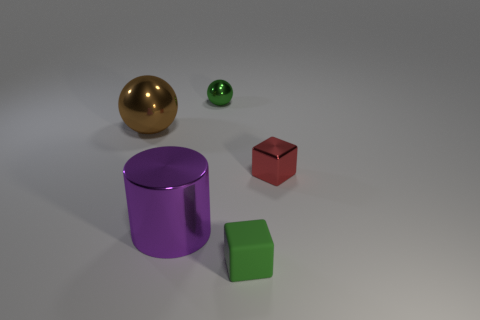Is the size of the green thing behind the green cube the same as the green matte block?
Ensure brevity in your answer.  Yes. There is a thing that is on the right side of the purple thing and behind the small red shiny thing; what shape is it?
Make the answer very short. Sphere. There is a large sphere; does it have the same color as the tiny object on the right side of the matte cube?
Make the answer very short. No. There is a metal ball that is on the left side of the big object in front of the metal object that is on the left side of the cylinder; what color is it?
Offer a very short reply. Brown. The other object that is the same shape as the red shiny object is what color?
Your response must be concise. Green. Are there the same number of brown metal objects behind the brown ball and metal spheres?
Your answer should be compact. No. How many balls are small green objects or big things?
Offer a terse response. 2. The big cylinder that is made of the same material as the small red block is what color?
Offer a terse response. Purple. Does the purple cylinder have the same material as the small green thing in front of the tiny red metallic block?
Make the answer very short. No. How many things are either large red shiny blocks or small green rubber blocks?
Your answer should be very brief. 1. 